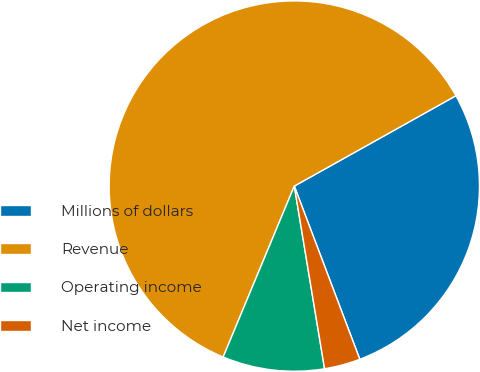<chart> <loc_0><loc_0><loc_500><loc_500><pie_chart><fcel>Millions of dollars<fcel>Revenue<fcel>Operating income<fcel>Net income<nl><fcel>27.36%<fcel>60.61%<fcel>8.89%<fcel>3.14%<nl></chart> 